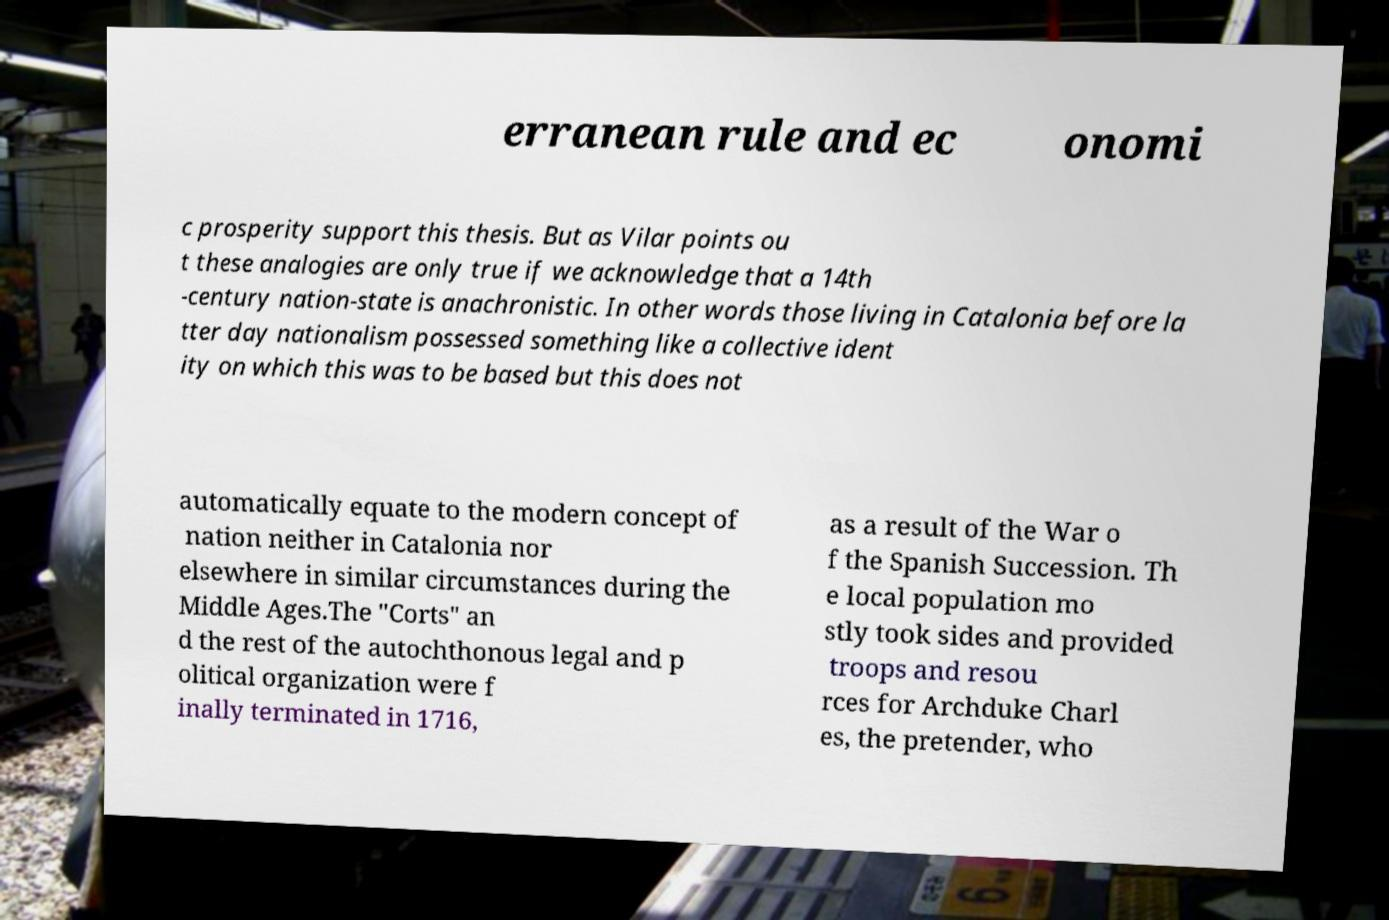I need the written content from this picture converted into text. Can you do that? erranean rule and ec onomi c prosperity support this thesis. But as Vilar points ou t these analogies are only true if we acknowledge that a 14th -century nation-state is anachronistic. In other words those living in Catalonia before la tter day nationalism possessed something like a collective ident ity on which this was to be based but this does not automatically equate to the modern concept of nation neither in Catalonia nor elsewhere in similar circumstances during the Middle Ages.The "Corts" an d the rest of the autochthonous legal and p olitical organization were f inally terminated in 1716, as a result of the War o f the Spanish Succession. Th e local population mo stly took sides and provided troops and resou rces for Archduke Charl es, the pretender, who 